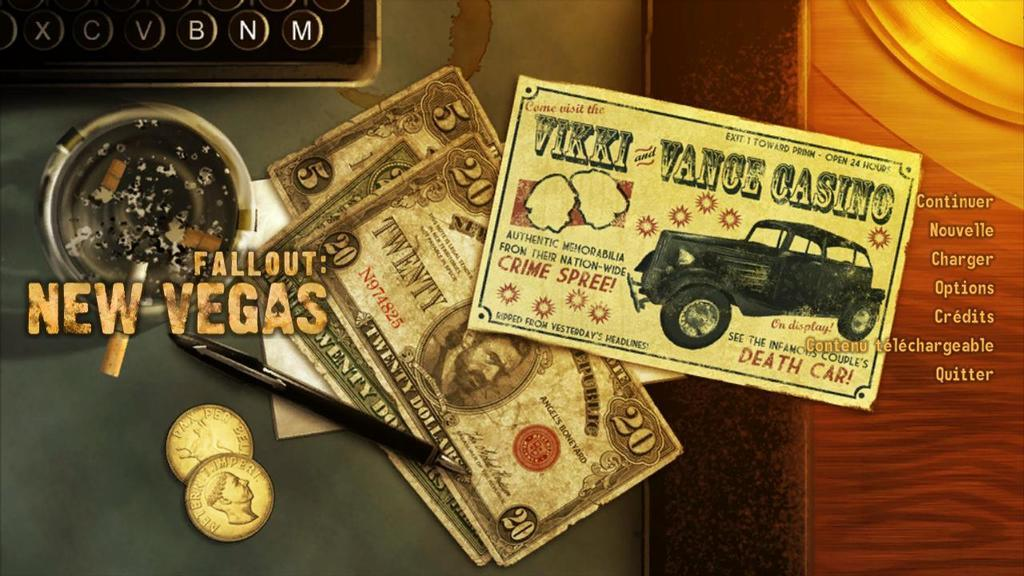<image>
Describe the image concisely. Old paper money is shown with a Vikki Vance Casino card for the game Fallout New Vegas. 